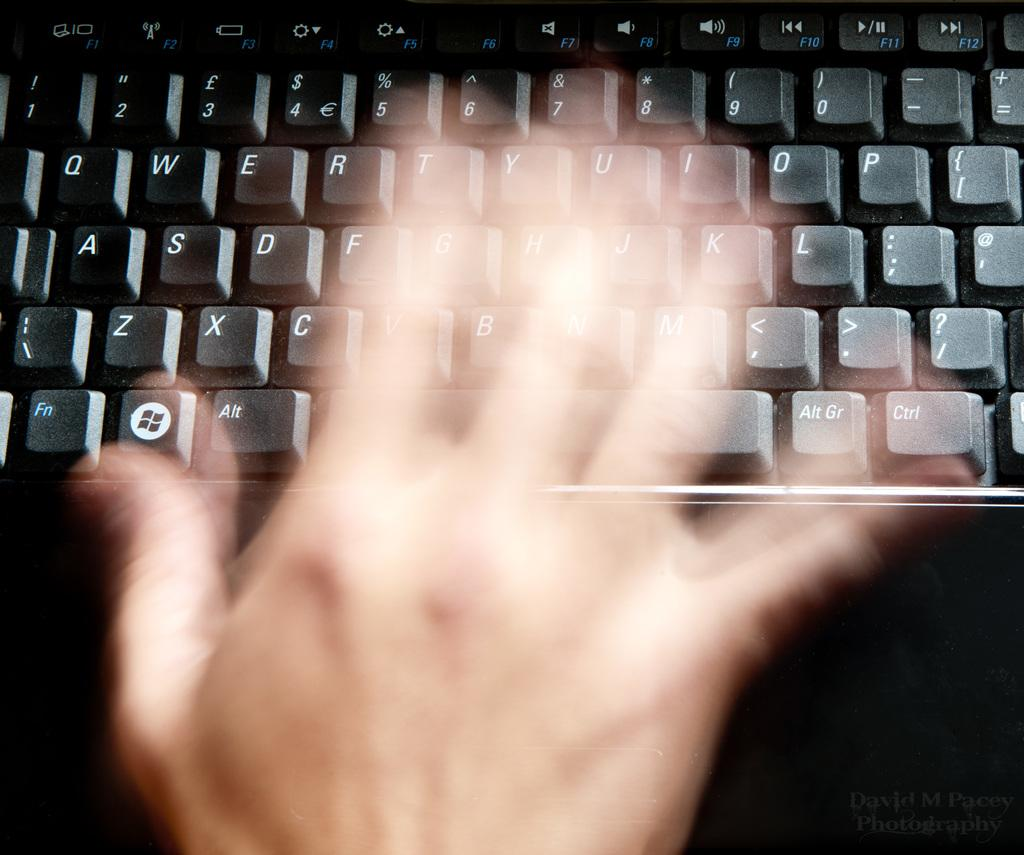<image>
Summarize the visual content of the image. QWERTY standard keys are shown on this keyboard. 